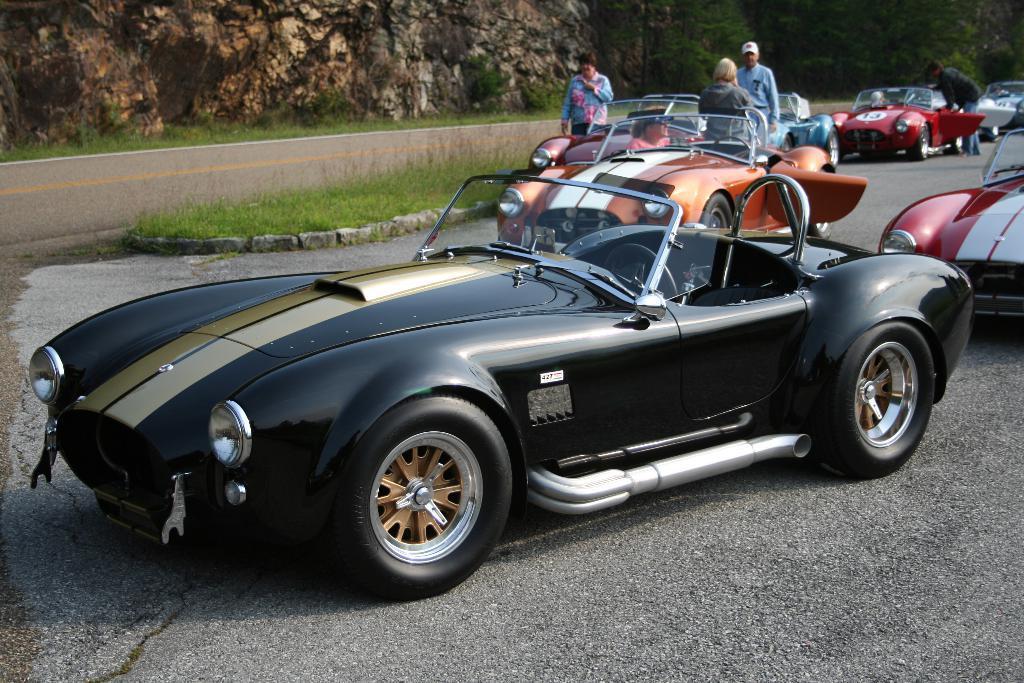Describe this image in one or two sentences. In this picture we can see cars, there are four persons and grass in the middle, in the background there are trees and it looks like a rock. 